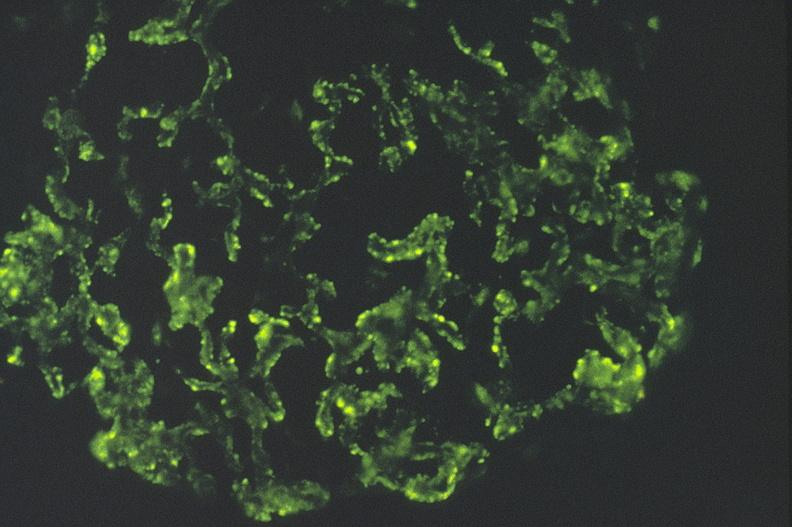what is present?
Answer the question using a single word or phrase. Urinary 